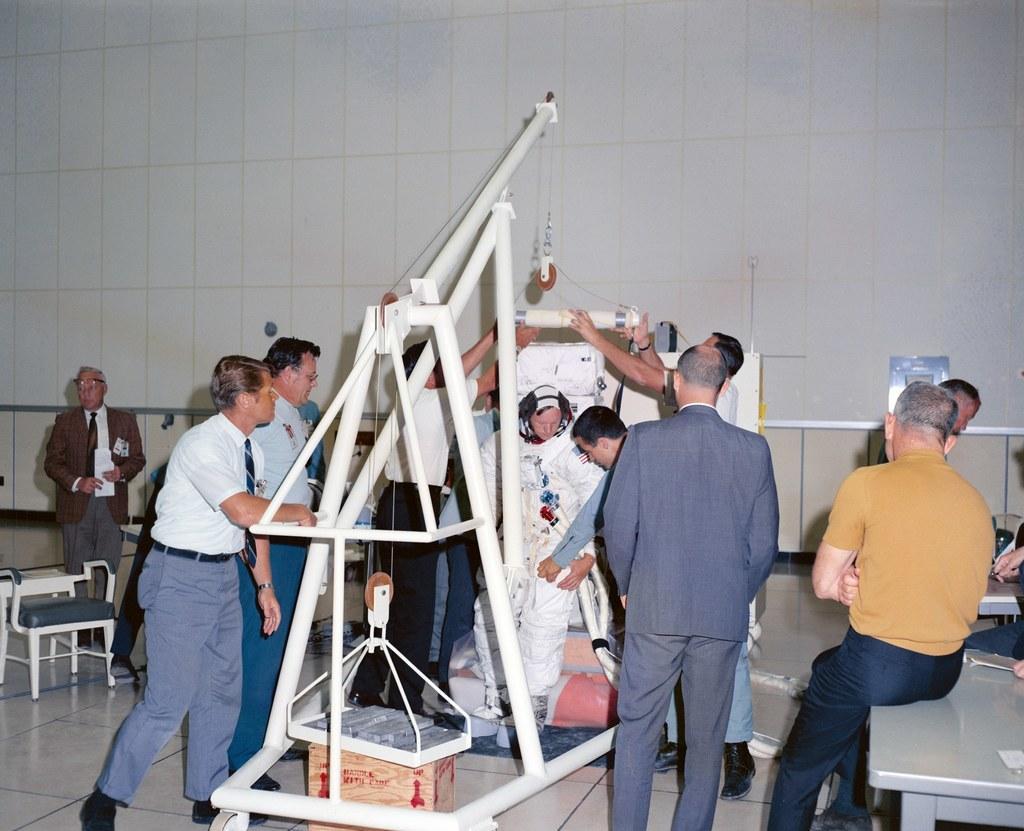Could you give a brief overview of what you see in this image? In this picture there are people and we can see rods, cardboard box, board, tables, chair, floor and objects. In the background of the image we can see the wall. 